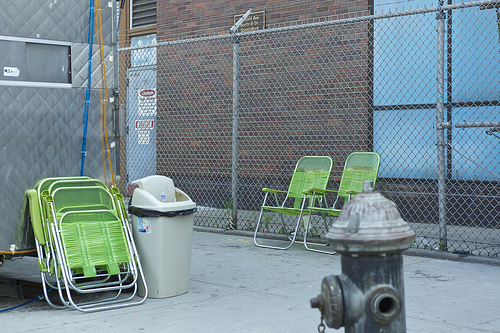<image>
Can you confirm if the bin is on the chair? No. The bin is not positioned on the chair. They may be near each other, but the bin is not supported by or resting on top of the chair. 